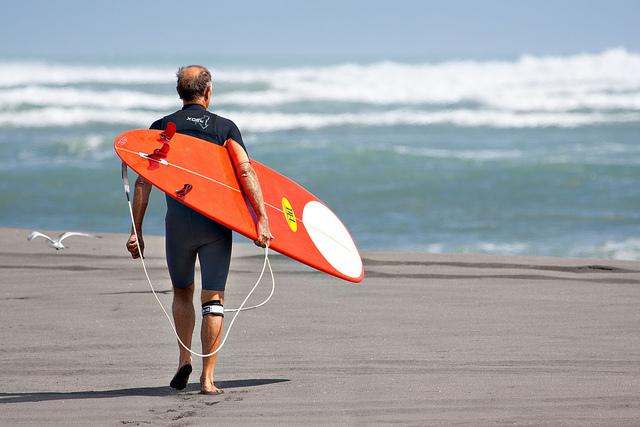What type of surf spot is this considered?
Give a very brief answer. Beach. Is there a bird in the picture?
Quick response, please. Yes. Is the man wearing a wetsuit?
Concise answer only. Yes. Is this a man or woman?
Concise answer only. Man. What is the board attached to?
Quick response, please. Leg. 